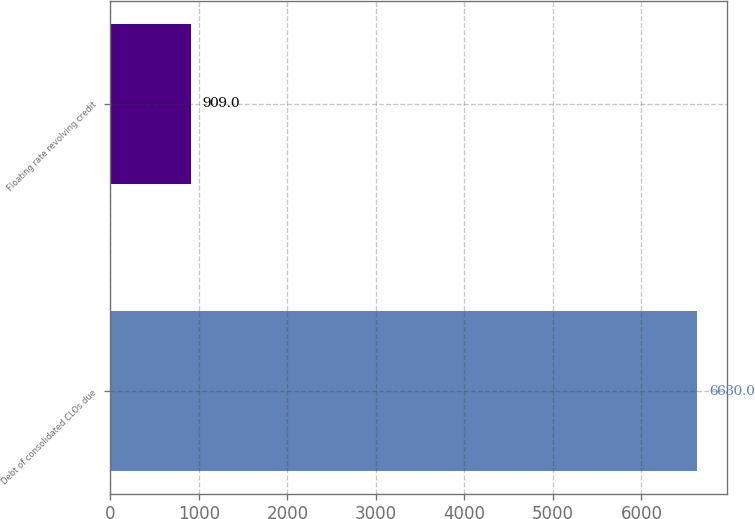Convert chart. <chart><loc_0><loc_0><loc_500><loc_500><bar_chart><fcel>Debt of consolidated CLOs due<fcel>Floating rate revolving credit<nl><fcel>6630<fcel>909<nl></chart> 